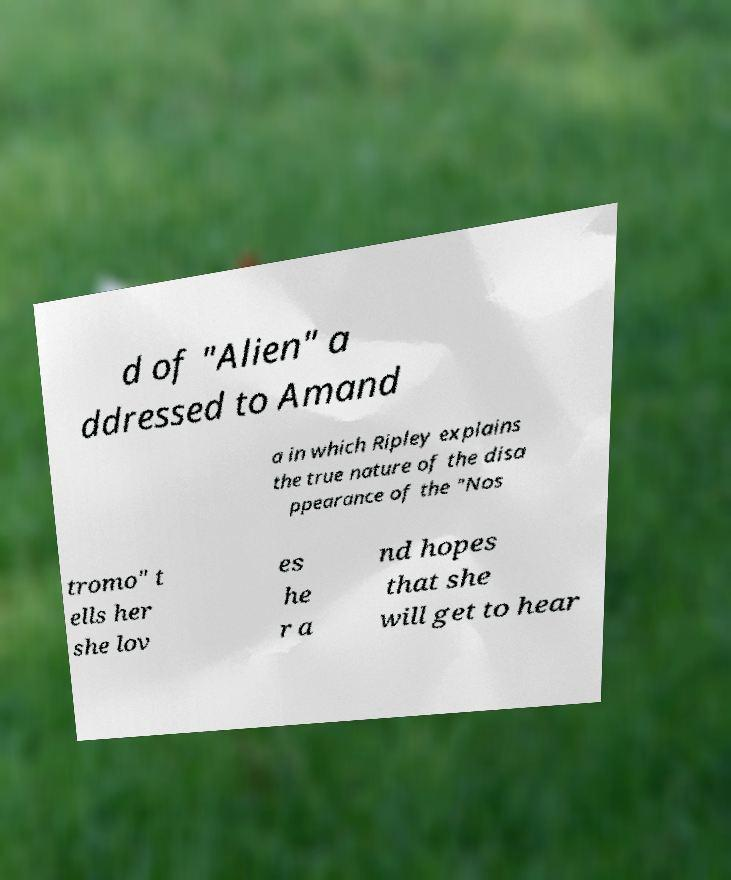I need the written content from this picture converted into text. Can you do that? d of "Alien" a ddressed to Amand a in which Ripley explains the true nature of the disa ppearance of the "Nos tromo" t ells her she lov es he r a nd hopes that she will get to hear 